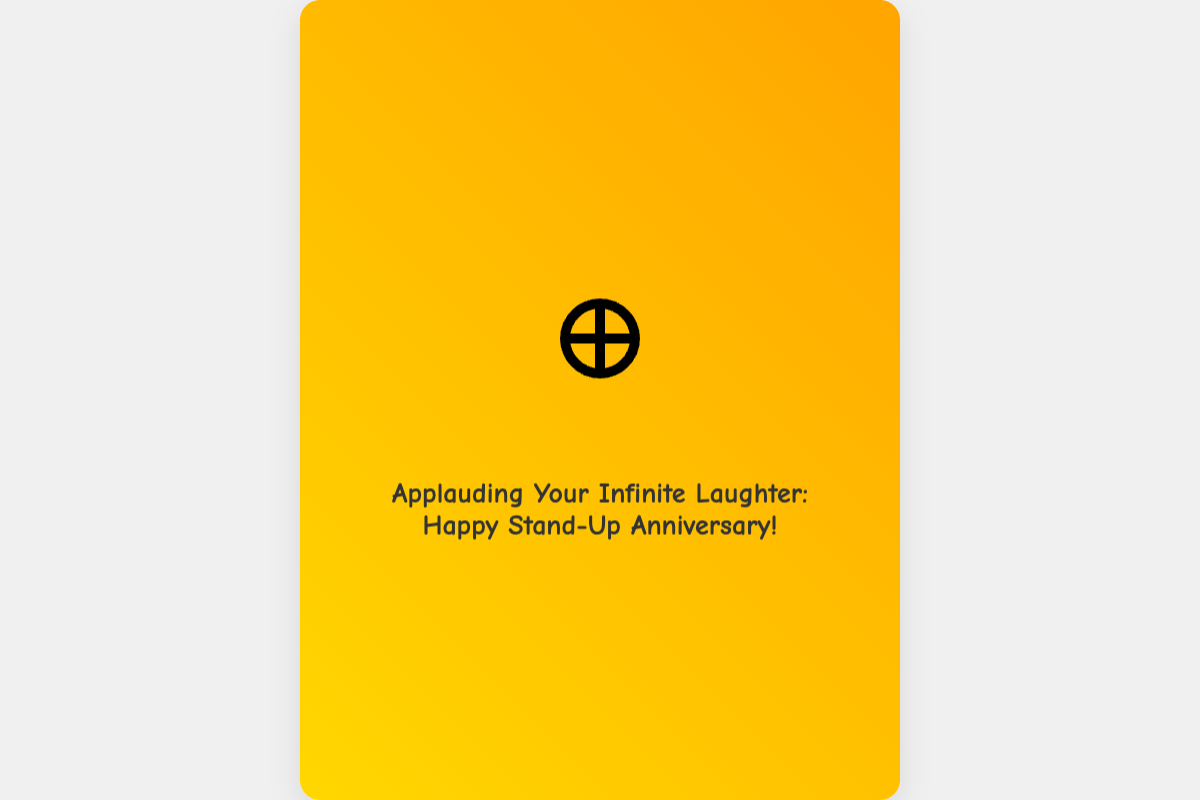What is the title of the card? The title is prominently displayed in the card's front section, celebrating the occasion.
Answer: Applauding Your Infinite Laughter: Happy Stand-Up Anniversary! What color is the card's background? The card's background features a gradient of colors that are visually appealing.
Answer: White What is represented by the infinity symbol in the design? The infinity symbol is interwoven with a microphone cable, symbolizing endless laughter in comedy.
Answer: Microphone cable What is one of the math jokes included in the card? The text includes humorous remarks related to mathematics and comedy, which add lightheartedness to the message.
Answer: When mathematicians find humor in numbers, they realize that comedy, like infinity, has no limits! What is the message about the comedian's humor? The sentiments expressed elaborate on the comedian's skills and joyful impact on others, likening their humor to mathematical concepts.
Answer: Your jokes have exponential growth, creating laughter at every stage! How does the card symbolize the relationship between math and comedy? The card intertwines humor with mathematical concepts, showing their connection in promoting joy and laughter.
Answer: Perfect match like sine and cosine What is the significance of the number π mentioned in the card? The mention of π emphasizes the idea of infinity and suggests the unlimited reach of the comedian's humor.
Answer: Infinite as the solutions to pi Who is the card's message directed to? The greeting card is specifically intended for a comedian, celebrating their anniversary in stand-up comedy.
Answer: A comedian Which font style is used for the headings in the card? The font style enhances the comedy theme of the card, making it visually distinctive.
Answer: Comic Neue What does the signature section convey? The closing line reinforces the theme of infinite laughter, tying together the card's overall message of appreciation.
Answer: To a comedian whose humor stretches to infinity and beyond - may your punchlines never have an endpoint! 